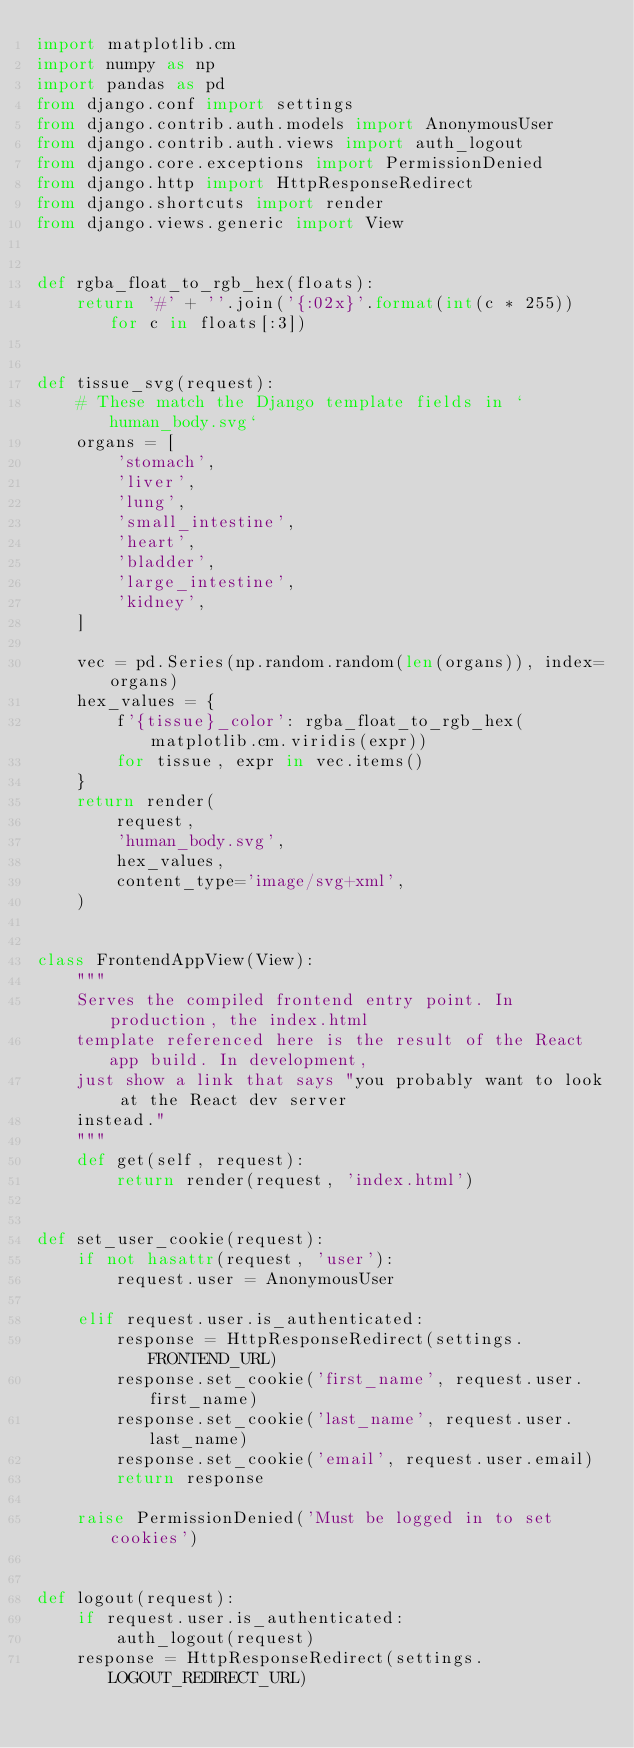<code> <loc_0><loc_0><loc_500><loc_500><_Python_>import matplotlib.cm
import numpy as np
import pandas as pd
from django.conf import settings
from django.contrib.auth.models import AnonymousUser
from django.contrib.auth.views import auth_logout
from django.core.exceptions import PermissionDenied
from django.http import HttpResponseRedirect
from django.shortcuts import render
from django.views.generic import View


def rgba_float_to_rgb_hex(floats):
    return '#' + ''.join('{:02x}'.format(int(c * 255)) for c in floats[:3])


def tissue_svg(request):
    # These match the Django template fields in `human_body.svg`
    organs = [
        'stomach',
        'liver',
        'lung',
        'small_intestine',
        'heart',
        'bladder',
        'large_intestine',
        'kidney',
    ]

    vec = pd.Series(np.random.random(len(organs)), index=organs)
    hex_values = {
        f'{tissue}_color': rgba_float_to_rgb_hex(matplotlib.cm.viridis(expr))
        for tissue, expr in vec.items()
    }
    return render(
        request,
        'human_body.svg',
        hex_values,
        content_type='image/svg+xml',
    )


class FrontendAppView(View):
    """
    Serves the compiled frontend entry point. In production, the index.html
    template referenced here is the result of the React app build. In development,
    just show a link that says "you probably want to look at the React dev server
    instead."
    """
    def get(self, request):
        return render(request, 'index.html')


def set_user_cookie(request):
    if not hasattr(request, 'user'):
        request.user = AnonymousUser

    elif request.user.is_authenticated:
        response = HttpResponseRedirect(settings.FRONTEND_URL)
        response.set_cookie('first_name', request.user.first_name)
        response.set_cookie('last_name', request.user.last_name)
        response.set_cookie('email', request.user.email)
        return response

    raise PermissionDenied('Must be logged in to set cookies')


def logout(request):
    if request.user.is_authenticated:
        auth_logout(request)
    response = HttpResponseRedirect(settings.LOGOUT_REDIRECT_URL)</code> 